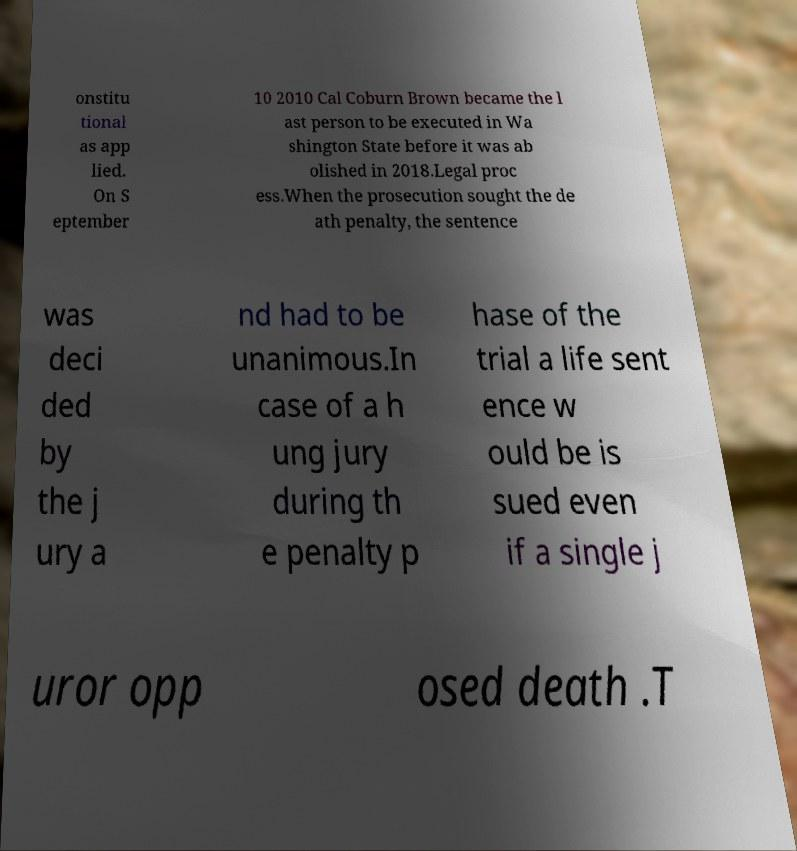Could you assist in decoding the text presented in this image and type it out clearly? onstitu tional as app lied. On S eptember 10 2010 Cal Coburn Brown became the l ast person to be executed in Wa shington State before it was ab olished in 2018.Legal proc ess.When the prosecution sought the de ath penalty, the sentence was deci ded by the j ury a nd had to be unanimous.In case of a h ung jury during th e penalty p hase of the trial a life sent ence w ould be is sued even if a single j uror opp osed death .T 